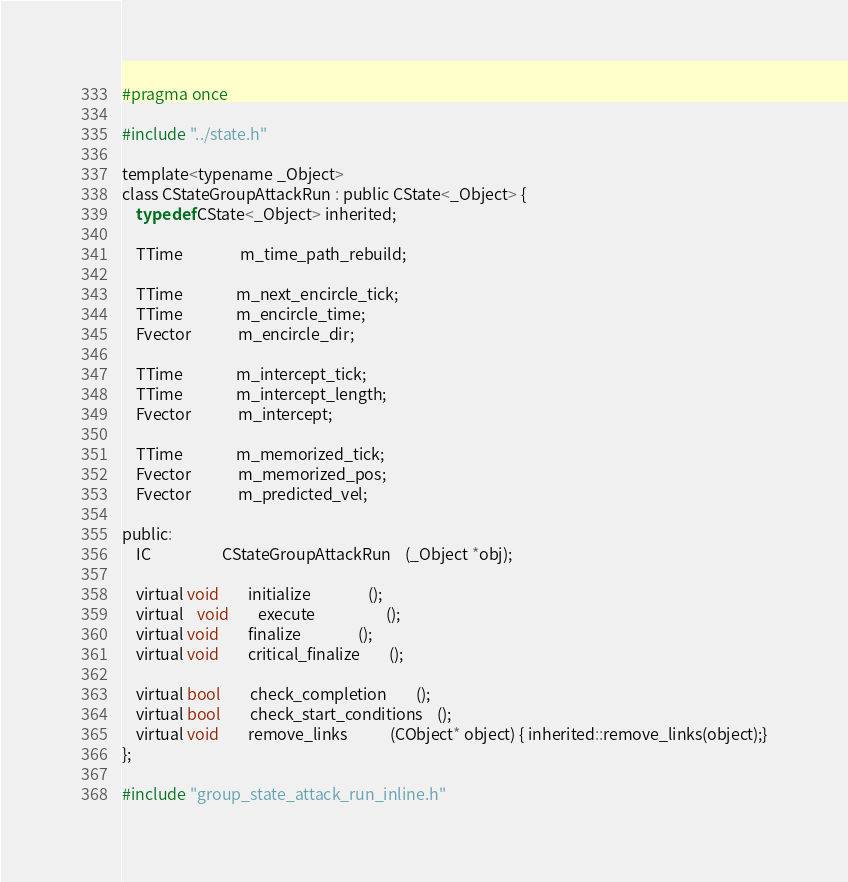Convert code to text. <code><loc_0><loc_0><loc_500><loc_500><_C_>#pragma once

#include "../state.h"

template<typename _Object>
class CStateGroupAttackRun : public CState<_Object> {
	typedef CState<_Object> inherited;

	TTime				m_time_path_rebuild;
	
	TTime               m_next_encircle_tick;
	TTime               m_encircle_time;
	Fvector             m_encircle_dir;

	TTime               m_intercept_tick;
	TTime               m_intercept_length;
	Fvector             m_intercept;

	TTime               m_memorized_tick;
	Fvector             m_memorized_pos;
	Fvector             m_predicted_vel;

public:
	IC					CStateGroupAttackRun	(_Object *obj);

	virtual void		initialize				();
	virtual	void		execute					();
	virtual void		finalize				();
	virtual void		critical_finalize		();

	virtual bool 		check_completion		();
	virtual bool 		check_start_conditions	();
	virtual void		remove_links			(CObject* object) { inherited::remove_links(object);}
};

#include "group_state_attack_run_inline.h"
</code> 